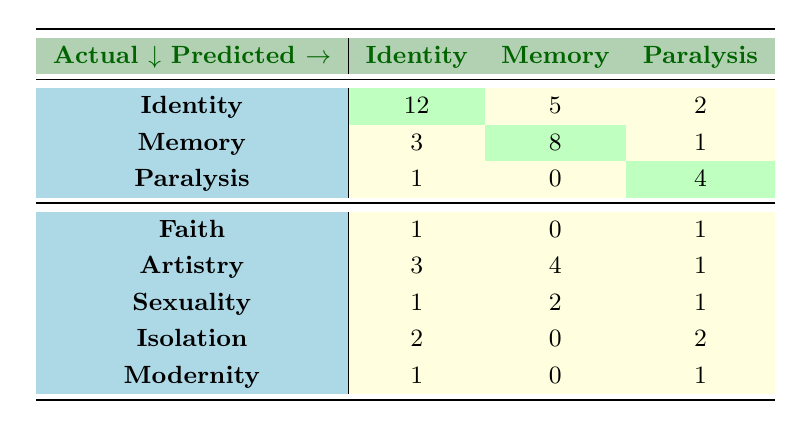What is the count of feedback for “Identity” predicted as “Identity”? The table indicates that the count of feedback for “Identity” predicted as “Identity” is explicitly listed at 12.
Answer: 12 How many feedback counts predicted as “Memory” are actually classified as “Memory”? The table shows that the feedback for “Memory” predicted as “Memory” has a count of 8, which is a straightforward lookup.
Answer: 8 What is the total count of feedback entries predicted as “Artistry”? Adding the counts for “Artistry” from the table, we have: 3 (Identity) + 4 (Memory) + 1 (Paralysis) = 8.
Answer: 8 Is it true that the predicted feedback for “Faith” has a count of zero for “Memory”? The table shows that the count for “Faith” predicted as “Memory” is outlined, and it is indeed 0. Therefore, the statement is true.
Answer: Yes What is the difference between the counts of feedback for “Isolation” predicted as “Paralysis” and those predicted as “Identity”? The count for “Isolation” predicted as “Paralysis” is 2 and for “Identity” is 2. The difference (2 - 2) equals 0.
Answer: 0 What is the highest feedback count among the actual categories of “Identity,” “Memory,” and “Paralysis”? For these three categories, the highest count is for “Identity” as predicted with a value of 12, compared to 8 (Memory) and 4 (Paralysis).
Answer: 12 How many feedback counts predicted as “Sexuality” are classified under “Memory”? The table indicates that the count of feedback for “Sexuality” predicted as “Memory” is 2.
Answer: 2 What is the total count of feedback classified under “Paralysis” for all predictions? The counts for “Paralysis” are: 1 (from Identity) + 0 (from Memory) + 4 (from Paralysis) + 1 (from Faith) + 1 (from Artistry) + 1 (from Sexuality) + 2 (from Isolation) + 1 (from Modernity) = 11.
Answer: 11 What is the predicted count for “Modernity” under “Memory”? The table reveals that the predicted count for “Modernity” under “Memory” is 0.
Answer: 0 